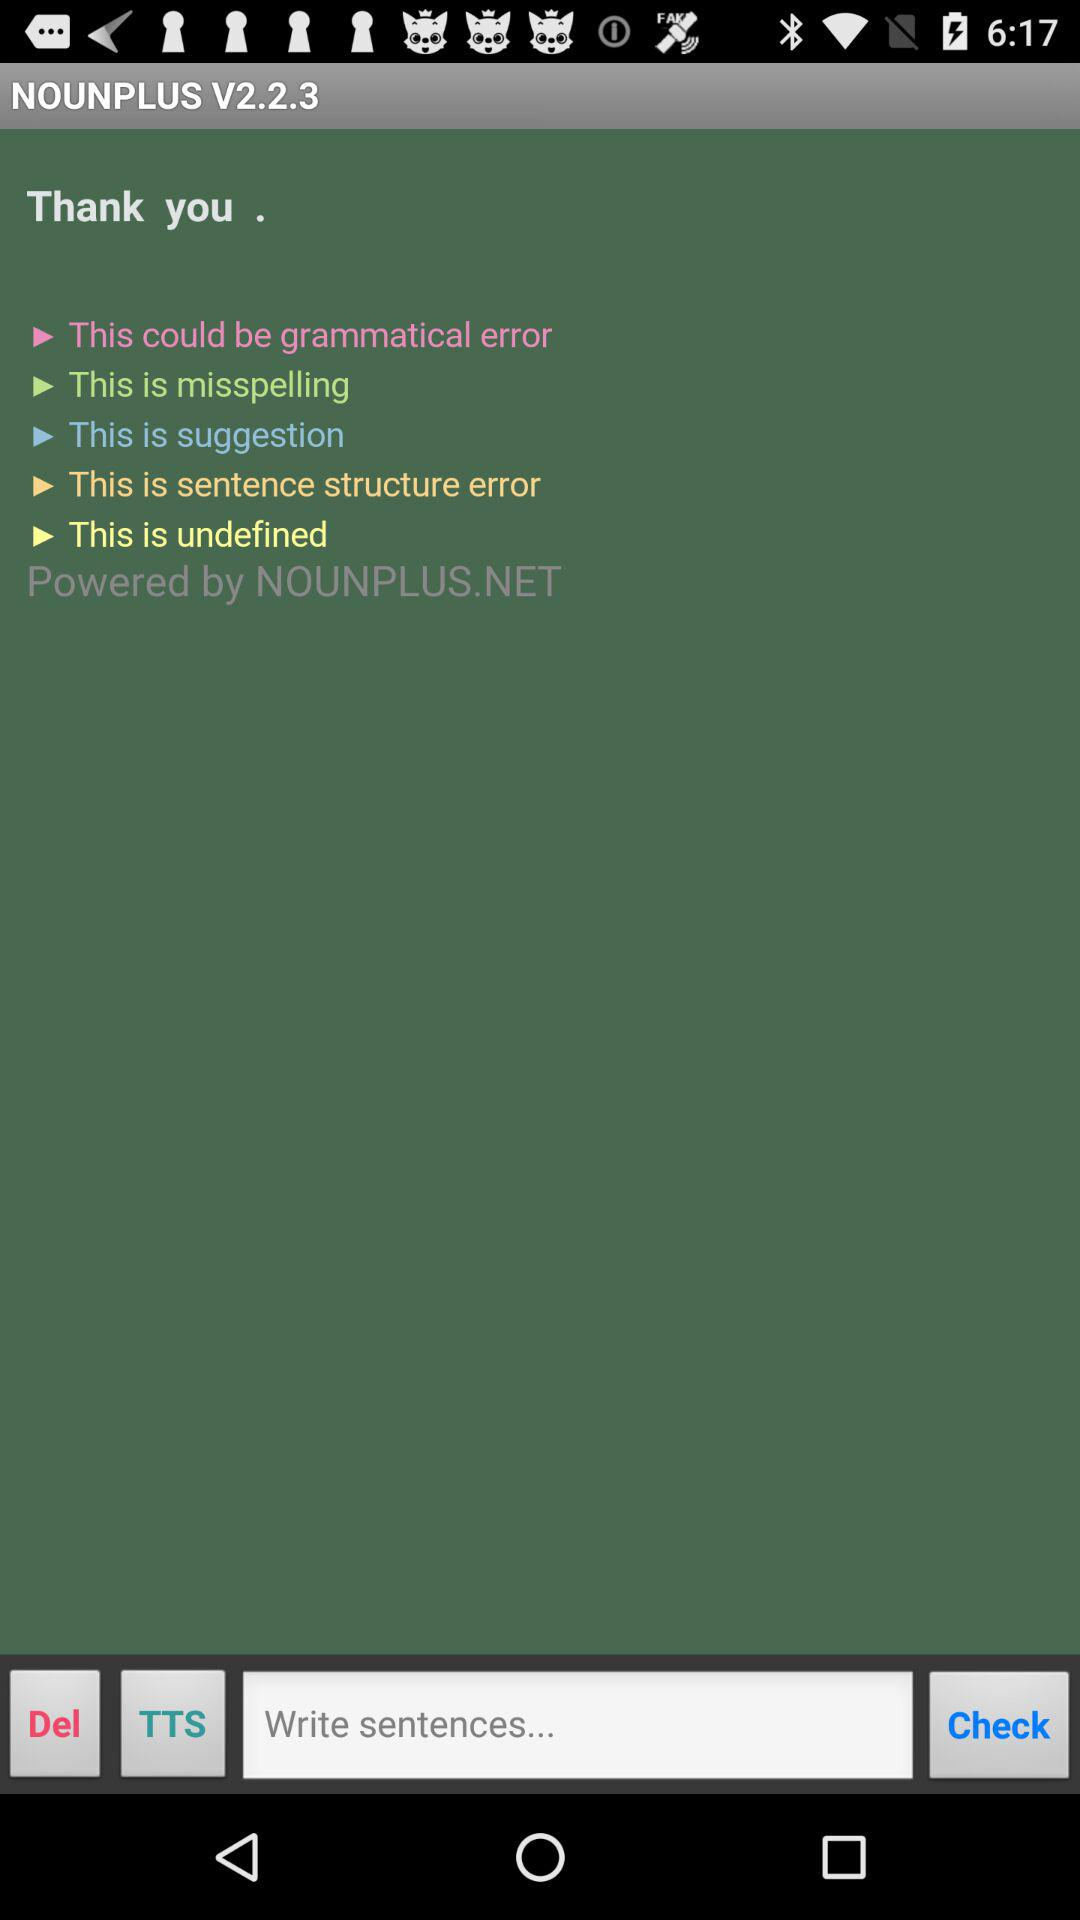Which version is used? The used version is V2.2.3. 